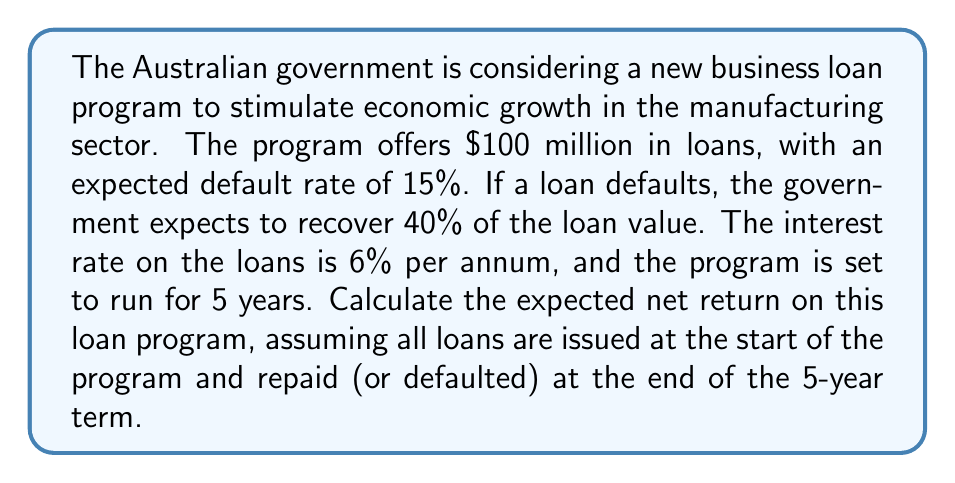Solve this math problem. To solve this problem, we need to consider both the potential returns and losses from the loan program:

1. Calculate the total loan amount:
   $100 million

2. Calculate the expected default amount:
   $100 million * 15% = $15 million

3. Calculate the expected non-default amount:
   $100 million - $15 million = $85 million

4. Calculate the recovery from defaults:
   $15 million * 40% = $6 million

5. Calculate the interest earned on non-defaulted loans:
   $85 million * (1 + 0.06)^5 - $85 million = $28.61 million

6. Calculate the total return:
   Interest earned + Recovery from defaults = $28.61 million + $6 million = $34.61 million

7. Calculate the net return:
   Total return - Default loss = $34.61 million - $15 million = $19.61 million

8. Calculate the net return as a percentage:
   $$\text{Net Return } \% = \frac{\text{Net Return}}{\text{Total Loan Amount}} * 100\%$$
   $$= \frac{19.61}{100} * 100\% = 19.61\%$$

9. Calculate the annualized net return:
   $$\text{Annualized Net Return } \% = (1 + 0.1961)^{\frac{1}{5}} - 1 = 3.65\%$$

Thus, the expected net return on this loan program over 5 years is 19.61%, or 3.65% annualized.
Answer: The expected net return on the loan program is 19.61% over 5 years, or 3.65% annualized. 